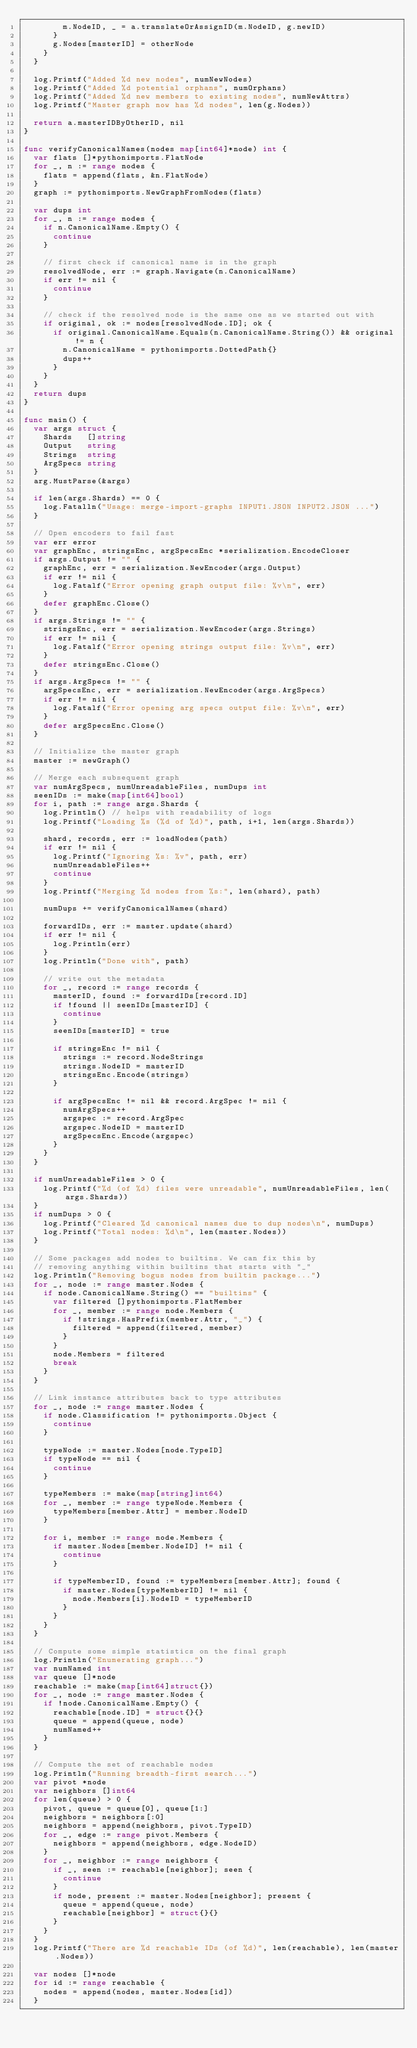<code> <loc_0><loc_0><loc_500><loc_500><_Go_>				m.NodeID, _ = a.translateOrAssignID(m.NodeID, g.newID)
			}
			g.Nodes[masterID] = otherNode
		}
	}

	log.Printf("Added %d new nodes", numNewNodes)
	log.Printf("Added %d potential orphans", numOrphans)
	log.Printf("Added %d new members to existing nodes", numNewAttrs)
	log.Printf("Master graph now has %d nodes", len(g.Nodes))

	return a.masterIDByOtherID, nil
}

func verifyCanonicalNames(nodes map[int64]*node) int {
	var flats []*pythonimports.FlatNode
	for _, n := range nodes {
		flats = append(flats, &n.FlatNode)
	}
	graph := pythonimports.NewGraphFromNodes(flats)

	var dups int
	for _, n := range nodes {
		if n.CanonicalName.Empty() {
			continue
		}

		// first check if canonical name is in the graph
		resolvedNode, err := graph.Navigate(n.CanonicalName)
		if err != nil {
			continue
		}

		// check if the resolved node is the same one as we started out with
		if original, ok := nodes[resolvedNode.ID]; ok {
			if original.CanonicalName.Equals(n.CanonicalName.String()) && original != n {
				n.CanonicalName = pythonimports.DottedPath{}
				dups++
			}
		}
	}
	return dups
}

func main() {
	var args struct {
		Shards   []string
		Output   string
		Strings  string
		ArgSpecs string
	}
	arg.MustParse(&args)

	if len(args.Shards) == 0 {
		log.Fatalln("Usage: merge-import-graphs INPUT1.JSON INPUT2.JSON ...")
	}

	// Open encoders to fail fast
	var err error
	var graphEnc, stringsEnc, argSpecsEnc *serialization.EncodeCloser
	if args.Output != "" {
		graphEnc, err = serialization.NewEncoder(args.Output)
		if err != nil {
			log.Fatalf("Error opening graph output file: %v\n", err)
		}
		defer graphEnc.Close()
	}
	if args.Strings != "" {
		stringsEnc, err = serialization.NewEncoder(args.Strings)
		if err != nil {
			log.Fatalf("Error opening strings output file: %v\n", err)
		}
		defer stringsEnc.Close()
	}
	if args.ArgSpecs != "" {
		argSpecsEnc, err = serialization.NewEncoder(args.ArgSpecs)
		if err != nil {
			log.Fatalf("Error opening arg specs output file: %v\n", err)
		}
		defer argSpecsEnc.Close()
	}

	// Initialize the master graph
	master := newGraph()

	// Merge each subsequent graph
	var numArgSpecs, numUnreadableFiles, numDups int
	seenIDs := make(map[int64]bool)
	for i, path := range args.Shards {
		log.Println() // helps with readability of logs
		log.Printf("Loading %s (%d of %d)", path, i+1, len(args.Shards))

		shard, records, err := loadNodes(path)
		if err != nil {
			log.Printf("Ignoring %s: %v", path, err)
			numUnreadableFiles++
			continue
		}
		log.Printf("Merging %d nodes from %s:", len(shard), path)

		numDups += verifyCanonicalNames(shard)

		forwardIDs, err := master.update(shard)
		if err != nil {
			log.Println(err)
		}
		log.Println("Done with", path)

		// write out the metadata
		for _, record := range records {
			masterID, found := forwardIDs[record.ID]
			if !found || seenIDs[masterID] {
				continue
			}
			seenIDs[masterID] = true

			if stringsEnc != nil {
				strings := record.NodeStrings
				strings.NodeID = masterID
				stringsEnc.Encode(strings)
			}

			if argSpecsEnc != nil && record.ArgSpec != nil {
				numArgSpecs++
				argspec := record.ArgSpec
				argspec.NodeID = masterID
				argSpecsEnc.Encode(argspec)
			}
		}
	}

	if numUnreadableFiles > 0 {
		log.Printf("%d (of %d) files were unreadable", numUnreadableFiles, len(args.Shards))
	}
	if numDups > 0 {
		log.Printf("Cleared %d canonical names due to dup nodes\n", numDups)
		log.Printf("Total nodes: %d\n", len(master.Nodes))
	}

	// Some packages add nodes to builtins. We can fix this by
	// removing anything within builtins that starts with "_"
	log.Println("Removing bogus nodes from builtin package...")
	for _, node := range master.Nodes {
		if node.CanonicalName.String() == "builtins" {
			var filtered []pythonimports.FlatMember
			for _, member := range node.Members {
				if !strings.HasPrefix(member.Attr, "_") {
					filtered = append(filtered, member)
				}
			}
			node.Members = filtered
			break
		}
	}

	// Link instance attributes back to type attributes
	for _, node := range master.Nodes {
		if node.Classification != pythonimports.Object {
			continue
		}

		typeNode := master.Nodes[node.TypeID]
		if typeNode == nil {
			continue
		}

		typeMembers := make(map[string]int64)
		for _, member := range typeNode.Members {
			typeMembers[member.Attr] = member.NodeID
		}

		for i, member := range node.Members {
			if master.Nodes[member.NodeID] != nil {
				continue
			}

			if typeMemberID, found := typeMembers[member.Attr]; found {
				if master.Nodes[typeMemberID] != nil {
					node.Members[i].NodeID = typeMemberID
				}
			}
		}
	}

	// Compute some simple statistics on the final graph
	log.Println("Enumerating graph...")
	var numNamed int
	var queue []*node
	reachable := make(map[int64]struct{})
	for _, node := range master.Nodes {
		if !node.CanonicalName.Empty() {
			reachable[node.ID] = struct{}{}
			queue = append(queue, node)
			numNamed++
		}
	}

	// Compute the set of reachable nodes
	log.Println("Running breadth-first search...")
	var pivot *node
	var neighbors []int64
	for len(queue) > 0 {
		pivot, queue = queue[0], queue[1:]
		neighbors = neighbors[:0]
		neighbors = append(neighbors, pivot.TypeID)
		for _, edge := range pivot.Members {
			neighbors = append(neighbors, edge.NodeID)
		}
		for _, neighbor := range neighbors {
			if _, seen := reachable[neighbor]; seen {
				continue
			}
			if node, present := master.Nodes[neighbor]; present {
				queue = append(queue, node)
				reachable[neighbor] = struct{}{}
			}
		}
	}
	log.Printf("There are %d reachable IDs (of %d)", len(reachable), len(master.Nodes))

	var nodes []*node
	for id := range reachable {
		nodes = append(nodes, master.Nodes[id])
	}
</code> 